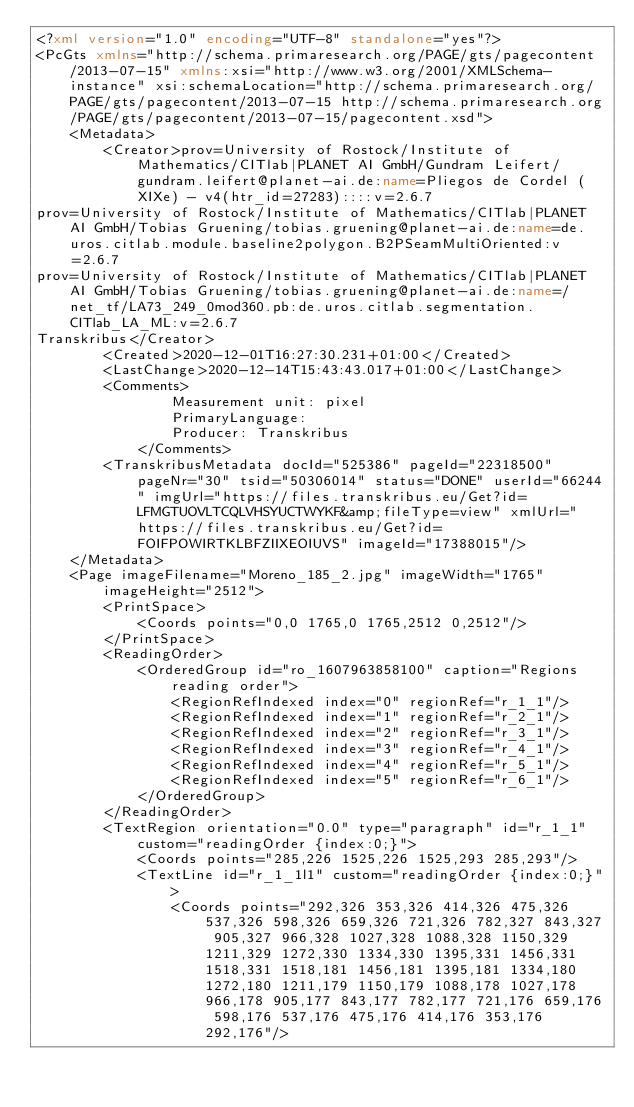<code> <loc_0><loc_0><loc_500><loc_500><_XML_><?xml version="1.0" encoding="UTF-8" standalone="yes"?>
<PcGts xmlns="http://schema.primaresearch.org/PAGE/gts/pagecontent/2013-07-15" xmlns:xsi="http://www.w3.org/2001/XMLSchema-instance" xsi:schemaLocation="http://schema.primaresearch.org/PAGE/gts/pagecontent/2013-07-15 http://schema.primaresearch.org/PAGE/gts/pagecontent/2013-07-15/pagecontent.xsd">
    <Metadata>
        <Creator>prov=University of Rostock/Institute of Mathematics/CITlab|PLANET AI GmbH/Gundram Leifert/gundram.leifert@planet-ai.de:name=Pliegos de Cordel (XIXe) - v4(htr_id=27283)::::v=2.6.7
prov=University of Rostock/Institute of Mathematics/CITlab|PLANET AI GmbH/Tobias Gruening/tobias.gruening@planet-ai.de:name=de.uros.citlab.module.baseline2polygon.B2PSeamMultiOriented:v=2.6.7
prov=University of Rostock/Institute of Mathematics/CITlab|PLANET AI GmbH/Tobias Gruening/tobias.gruening@planet-ai.de:name=/net_tf/LA73_249_0mod360.pb:de.uros.citlab.segmentation.CITlab_LA_ML:v=2.6.7
Transkribus</Creator>
        <Created>2020-12-01T16:27:30.231+01:00</Created>
        <LastChange>2020-12-14T15:43:43.017+01:00</LastChange>
        <Comments>
                Measurement unit: pixel
                PrimaryLanguage: 
                Producer: Transkribus
            </Comments>
        <TranskribusMetadata docId="525386" pageId="22318500" pageNr="30" tsid="50306014" status="DONE" userId="66244" imgUrl="https://files.transkribus.eu/Get?id=LFMGTUOVLTCQLVHSYUCTWYKF&amp;fileType=view" xmlUrl="https://files.transkribus.eu/Get?id=FOIFPOWIRTKLBFZIIXEOIUVS" imageId="17388015"/>
    </Metadata>
    <Page imageFilename="Moreno_185_2.jpg" imageWidth="1765" imageHeight="2512">
        <PrintSpace>
            <Coords points="0,0 1765,0 1765,2512 0,2512"/>
        </PrintSpace>
        <ReadingOrder>
            <OrderedGroup id="ro_1607963858100" caption="Regions reading order">
                <RegionRefIndexed index="0" regionRef="r_1_1"/>
                <RegionRefIndexed index="1" regionRef="r_2_1"/>
                <RegionRefIndexed index="2" regionRef="r_3_1"/>
                <RegionRefIndexed index="3" regionRef="r_4_1"/>
                <RegionRefIndexed index="4" regionRef="r_5_1"/>
                <RegionRefIndexed index="5" regionRef="r_6_1"/>
            </OrderedGroup>
        </ReadingOrder>
        <TextRegion orientation="0.0" type="paragraph" id="r_1_1" custom="readingOrder {index:0;}">
            <Coords points="285,226 1525,226 1525,293 285,293"/>
            <TextLine id="r_1_1l1" custom="readingOrder {index:0;}">
                <Coords points="292,326 353,326 414,326 475,326 537,326 598,326 659,326 721,326 782,327 843,327 905,327 966,328 1027,328 1088,328 1150,329 1211,329 1272,330 1334,330 1395,331 1456,331 1518,331 1518,181 1456,181 1395,181 1334,180 1272,180 1211,179 1150,179 1088,178 1027,178 966,178 905,177 843,177 782,177 721,176 659,176 598,176 537,176 475,176 414,176 353,176 292,176"/></code> 